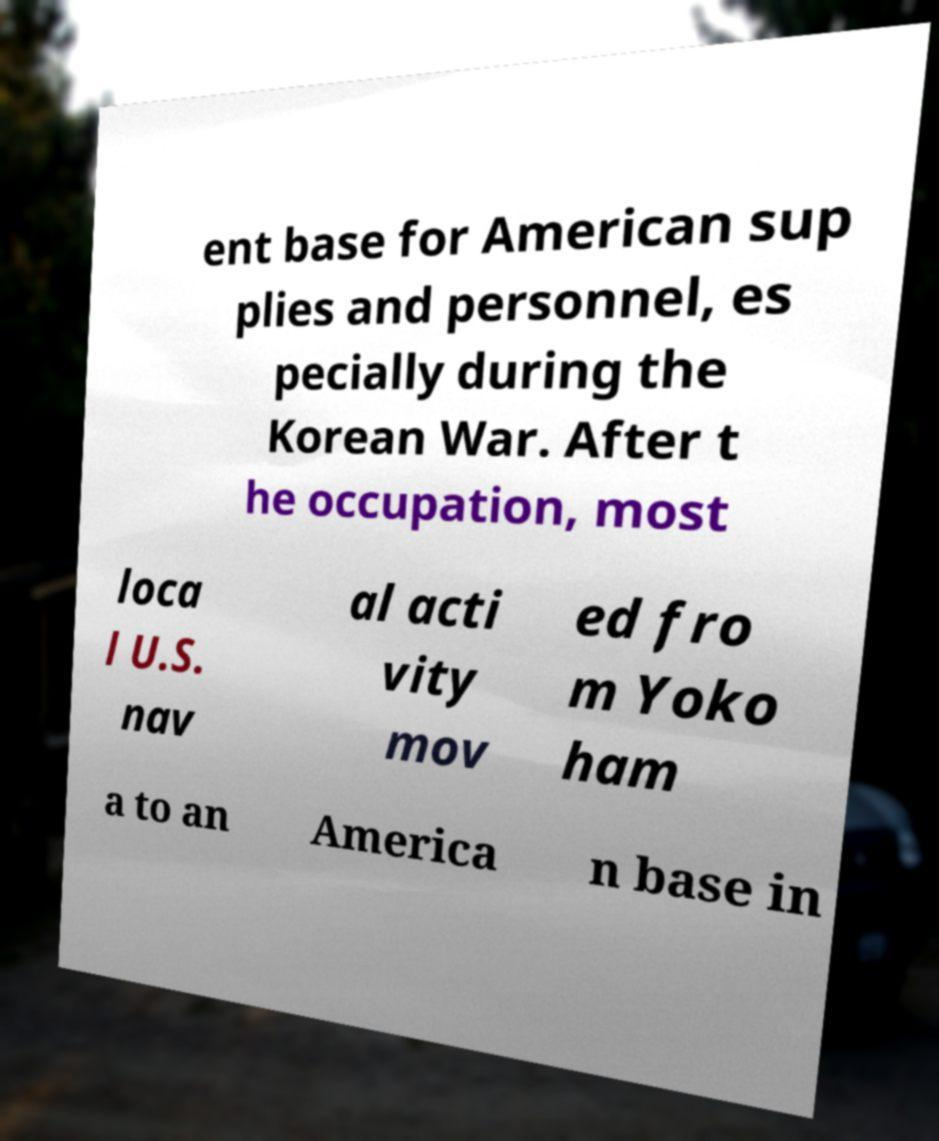Please identify and transcribe the text found in this image. ent base for American sup plies and personnel, es pecially during the Korean War. After t he occupation, most loca l U.S. nav al acti vity mov ed fro m Yoko ham a to an America n base in 